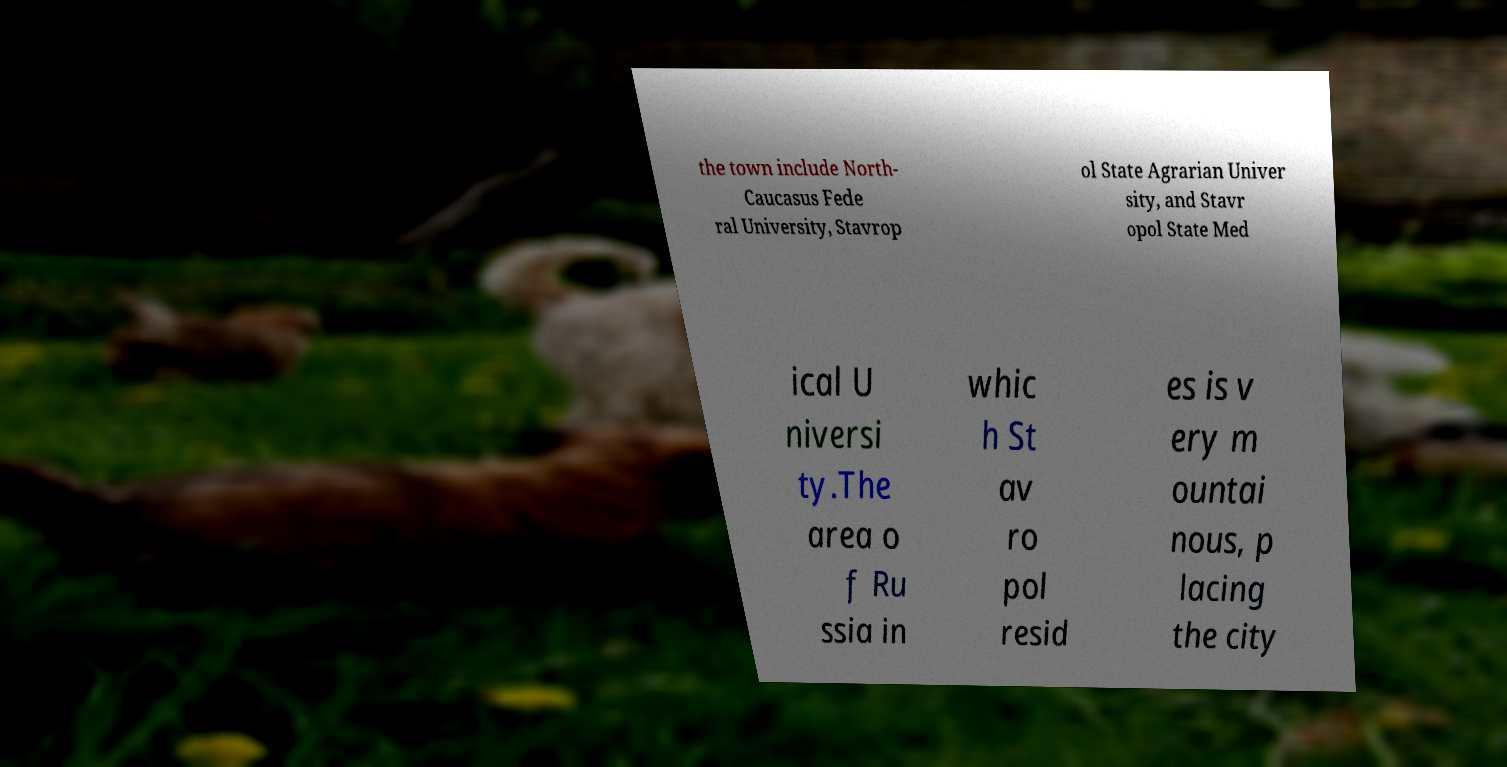Can you accurately transcribe the text from the provided image for me? the town include North- Caucasus Fede ral University, Stavrop ol State Agrarian Univer sity, and Stavr opol State Med ical U niversi ty.The area o f Ru ssia in whic h St av ro pol resid es is v ery m ountai nous, p lacing the city 